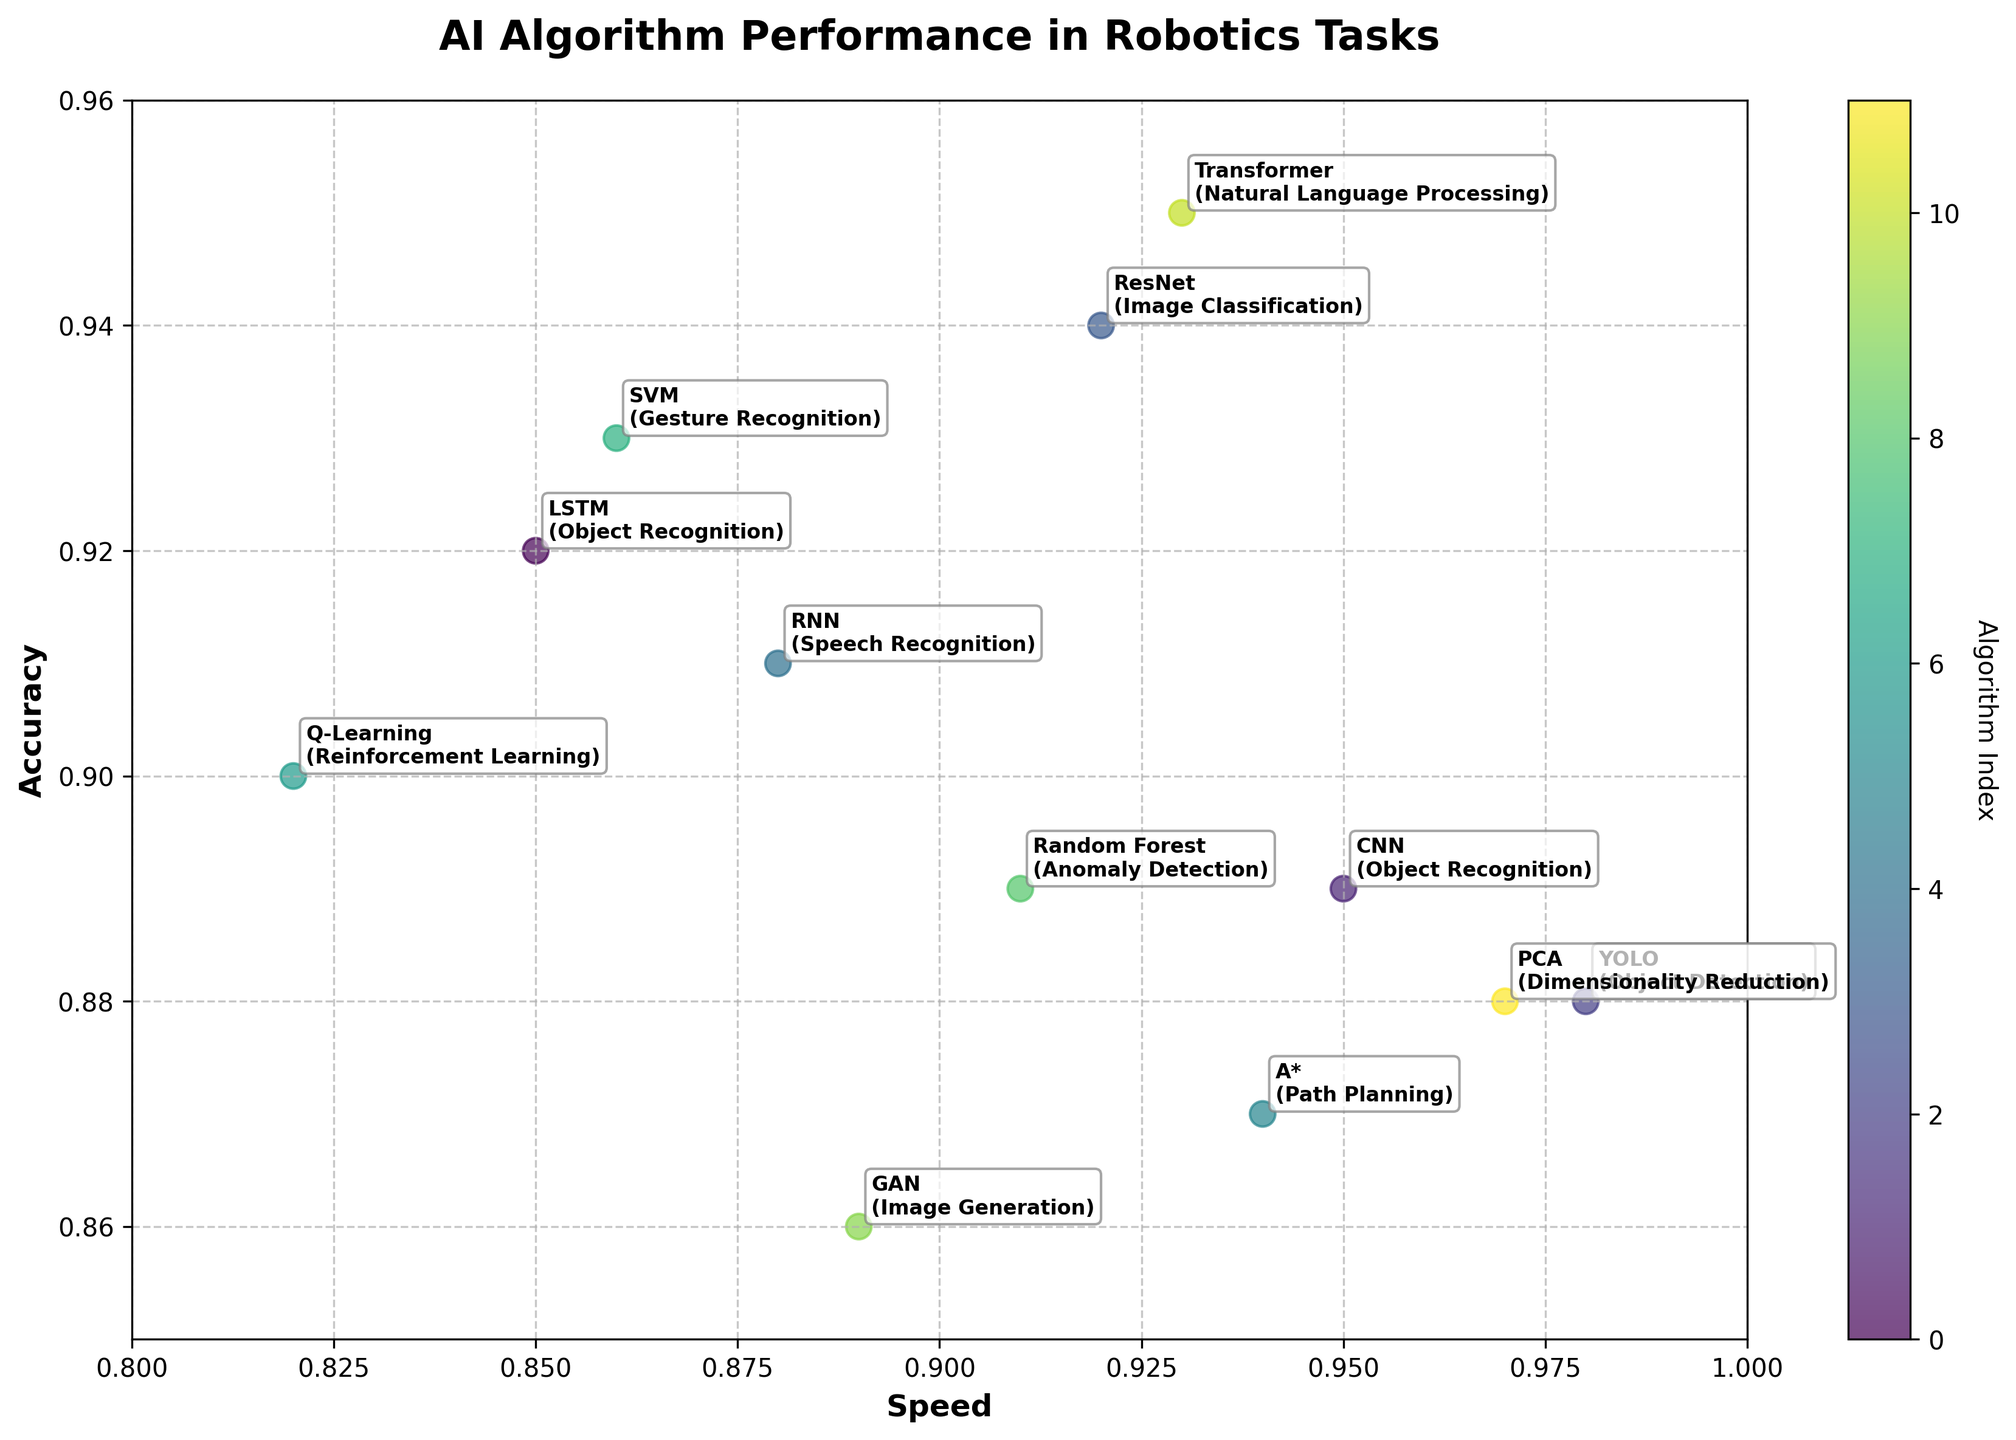What's the title of the figure? The title is located at the top of the figure and describes the overall topic or focus.
Answer: AI Algorithm Performance in Robotics Tasks What are the labels for the x-axis and y-axis? The labels are located along the x and y edges of the plot and describe what each axis represents. The x-axis label represents "Speed" and the y-axis label represents "Accuracy".
Answer: Speed and Accuracy How many algorithms have a speed greater than 0.9? To determine this, count the data points that are positioned to the right of the 0.9 mark on the x-axis. There are 8 algorithms: CNN, YOLO, ResNet, Random Forest, A*, Transformer, PCA, and LSTM.
Answer: 8 Which algorithm has the highest accuracy? The highest accuracy corresponds to the point that is farthest up along the y-axis. Transformer has the highest accuracy at 0.95.
Answer: Transformer What is the speed and accuracy of Q-Learning? Locate the point labeled Q-Learning and identify its coordinates on the x and y axes. Q-Learning has a speed of 0.82 and an accuracy of 0.90.
Answer: 0.82 and 0.90 Compare the speed and accuracy of LSTM and CNN. Locate the points labeled LSTM and CNN and compare their coordinates along the x and y axes. LSTM has a speed of 0.85 and an accuracy of 0.92, whereas CNN has a speed of 0.95 and an accuracy of 0.89. Therefore, CNN is faster but less accurate than LSTM.
Answer: CNN is faster but less accurate than LSTM Which tasks do the algorithms with accuracy less than 0.90 perform? Identify the points below the 0.90 mark on the y-axis and list their tasks. The tasks are Object Detection (YOLO), Path Planning (A*), and Image Generation (GAN).
Answer: Object Detection, Path Planning, Image Generation Which algorithm has the highest combined speed and accuracy? To find the highest combined value, add the speed and accuracy for each algorithm and identify the maximum value. Transformer (0.93 + 0.95 = 1.88) has the highest sum.
Answer: Transformer What is the difference in speed between YOLO and PCA? Subtract the speed of YOLO from the speed of PCA. The speeds are 0.98 for YOLO and 0.97 for PCA. The difference is 0.98 - 0.97 = 0.01.
Answer: 0.01 Is there any algorithm that has both higher speed and accuracy compared to RNN? Locate the point labeled RNN (speed 0.88, accuracy 0.91) and check for any points in the upper-right quadrant relative to RNN. Both ResNet and Transformer have higher values in both dimensions.
Answer: ResNet and Transformer 